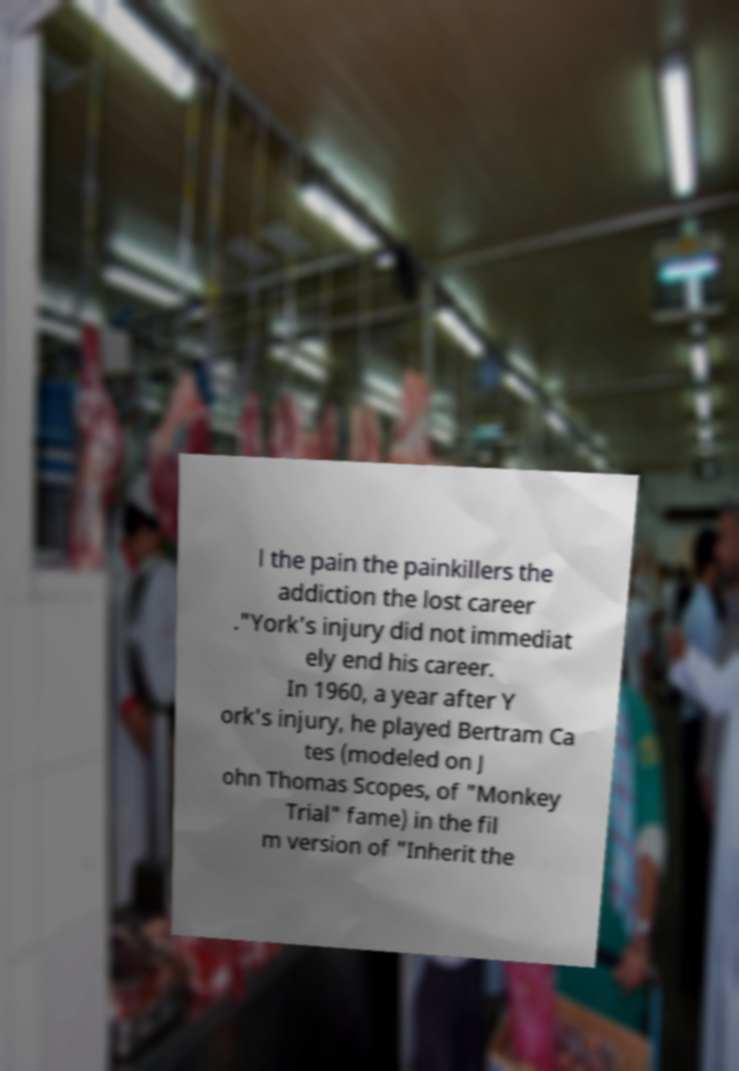Please read and relay the text visible in this image. What does it say? l the pain the painkillers the addiction the lost career ."York's injury did not immediat ely end his career. In 1960, a year after Y ork's injury, he played Bertram Ca tes (modeled on J ohn Thomas Scopes, of "Monkey Trial" fame) in the fil m version of "Inherit the 